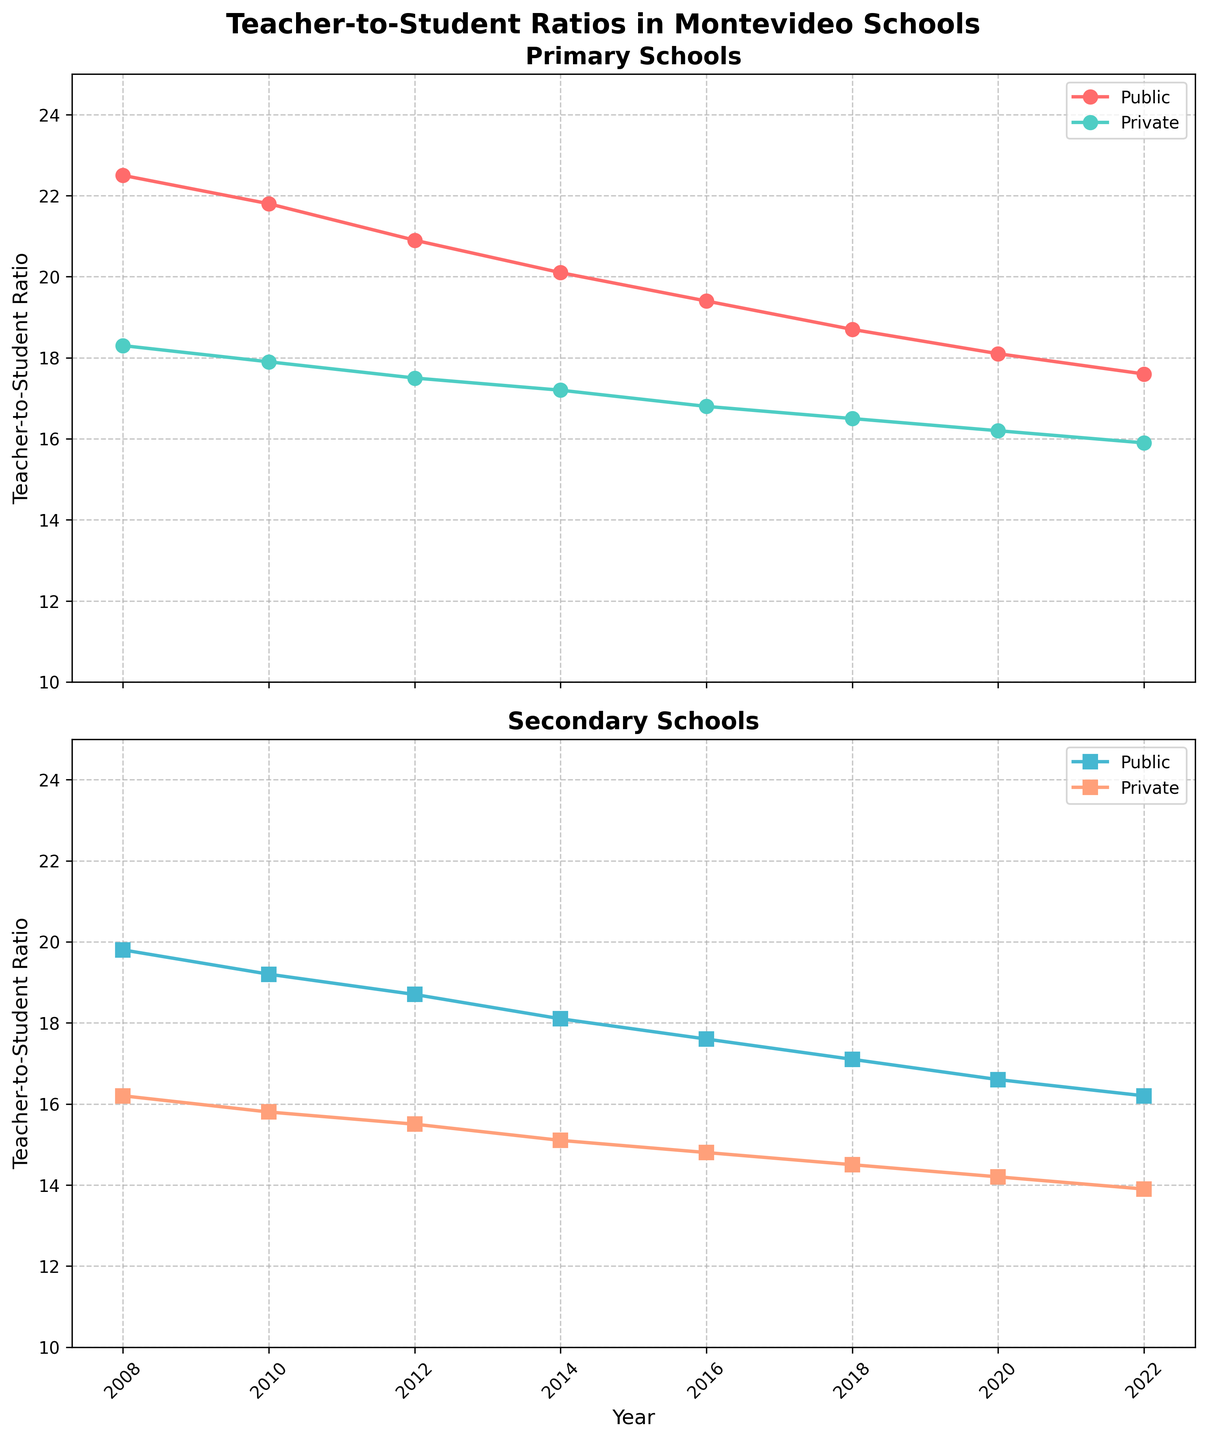What's the title of the figure? The title of the figure is located at the top and is usually bolded to stand out. Here, it reads "Teacher-to-Student Ratios in Montevideo Schools".
Answer: Teacher-to-Student Ratios in Montevideo Schools Which school type had the lowest teacher-to-student ratio in 2022? To determine this, look at the final data point (2022) in all four lines in both subplots and identify the one with the lowest value. It looks like the line representing Secondary Private schools has the lowest ratio around 13.9.
Answer: Secondary Private What trend is observed in the teacher-to-student ratio for Primary Public schools over the 15-year period? Observe the line representing Primary Public schools from 2008 to 2022; the line shows a clear downward trend, indicating that the teacher-to-student ratio has been decreasing over time.
Answer: Decreasing trend In which year did Primary Private schools have a teacher-to-student ratio of approximately 17.2? Look for the data point on the line representing Primary Private schools close to 17.2. It occurs around the year 2014.
Answer: 2014 Between Secondary Public and Secondary Private schools in 2016, which had a higher teacher-to-student ratio? Compare the heights of the two data points in 2016 for both Secondary Public and Secondary Private schools. Secondary Public has a ratio around 17.6, while Secondary Private is around 14.8, so Secondary Public has the higher ratio.
Answer: Secondary Public Calculate the average teacher-to-student ratio for Primary Public schools across the years provided. Sum the data points for Primary Public schools (22.5, 21.8, 20.9, 20.1, 19.4, 18.7, 18.1, 17.6) and divide by the number of data points (8). (22.5 + 21.8 + 20.9 + 20.1 + 19.4 + 18.7 + 18.1 + 17.6) / 8 = 159.1 / 8 = 19.89.
Answer: 19.89 Which school type shows the most significant change in the teacher-to-student ratio from 2008 to 2022? To determine this, calculate the difference between 2008 and 2022 ratios for all school types. Primary Public decreases from 22.5 to 17.6 (4.9), Primary Private from 18.3 to 15.9 (2.4), Secondary Public from 19.8 to 16.2 (3.6), and Secondary Private from 16.2 to 13.9 (2.3). The most significant change is in Primary Public.
Answer: Primary Public What is the difference in teacher-to-student ratios between Primary Private and Secondary Private schools in 2020? Subtract the 2020 ratio for Secondary Private schools from that for Primary Private schools: 16.2 (Primary Private) - 14.2 (Secondary Private) = 2.0.
Answer: 2.0 At what rate has the teacher-to-student ratio for Secondary Public schools decreased per year on average between 2008 and 2022? Calculate the total decrease first: 19.8 (2008) - 16.2 (2022) = 3.6. Then divide by the number of years: 3.6 / (2022 - 2008) = 3.6 / 14 = 0.257.
Answer: 0.257 per year 